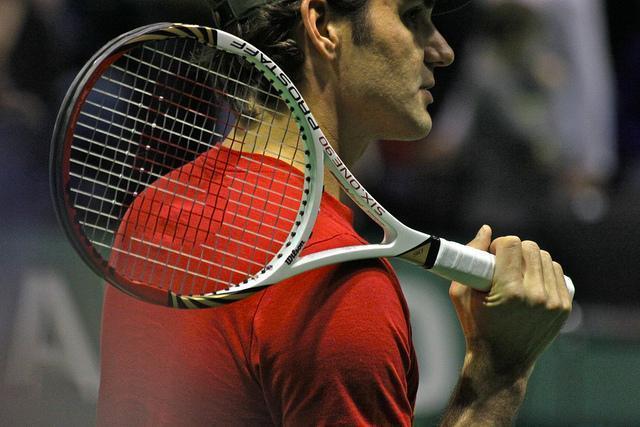How many people are in the photo?
Give a very brief answer. 1. How many blue keyboards are there?
Give a very brief answer. 0. 